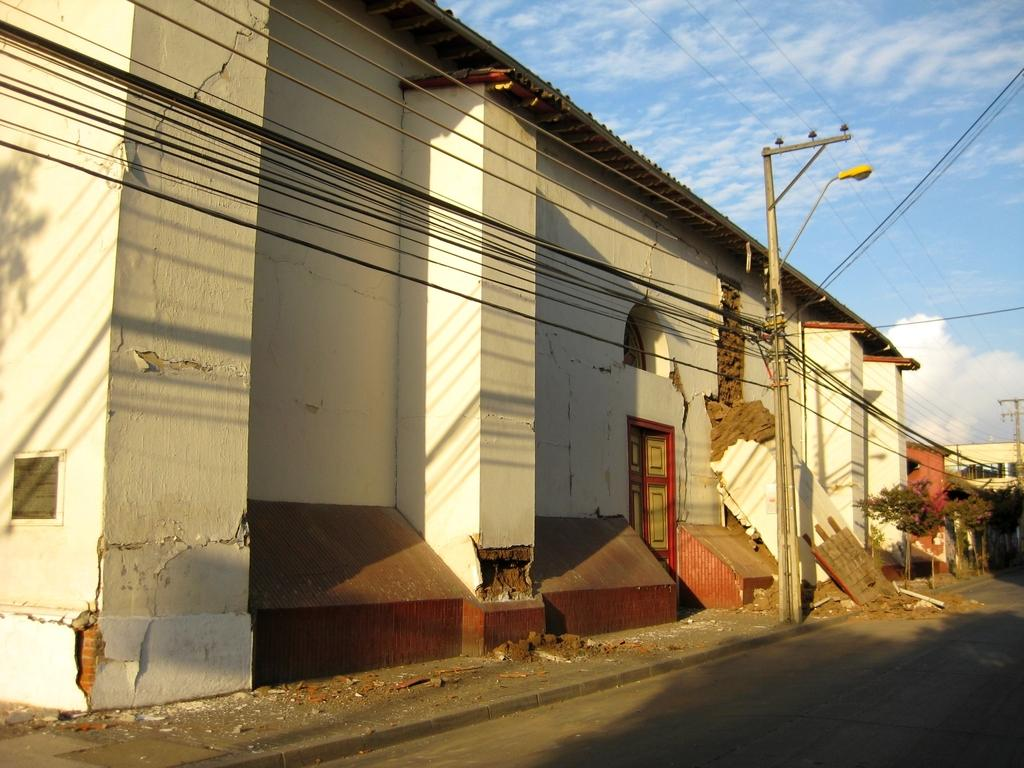What type of structure is visible in the image? There is a building in the image. What else can be seen in the image besides the building? There is a utility pole with electrical cables and a lamp on the utility pole. What is the surface in front of the utility pole? There is a road surface in front of the utility pole. Where are the scissors located in the image? There are no scissors present in the image. What type of apparatus is used to generate electricity in the image? The image does not show any apparatus used to generate electricity; it only shows electrical cables and a lamp on the utility pole. 